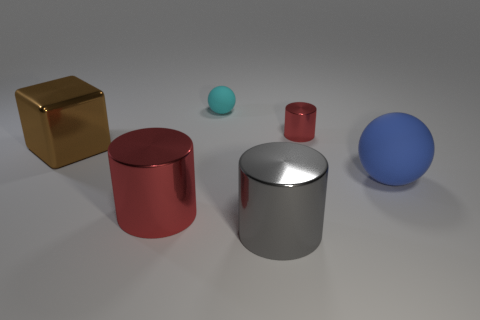Add 1 tiny purple metallic balls. How many objects exist? 7 Subtract all cubes. How many objects are left? 5 Add 2 shiny objects. How many shiny objects exist? 6 Subtract 1 red cylinders. How many objects are left? 5 Subtract all tiny purple objects. Subtract all red metallic objects. How many objects are left? 4 Add 5 large rubber objects. How many large rubber objects are left? 6 